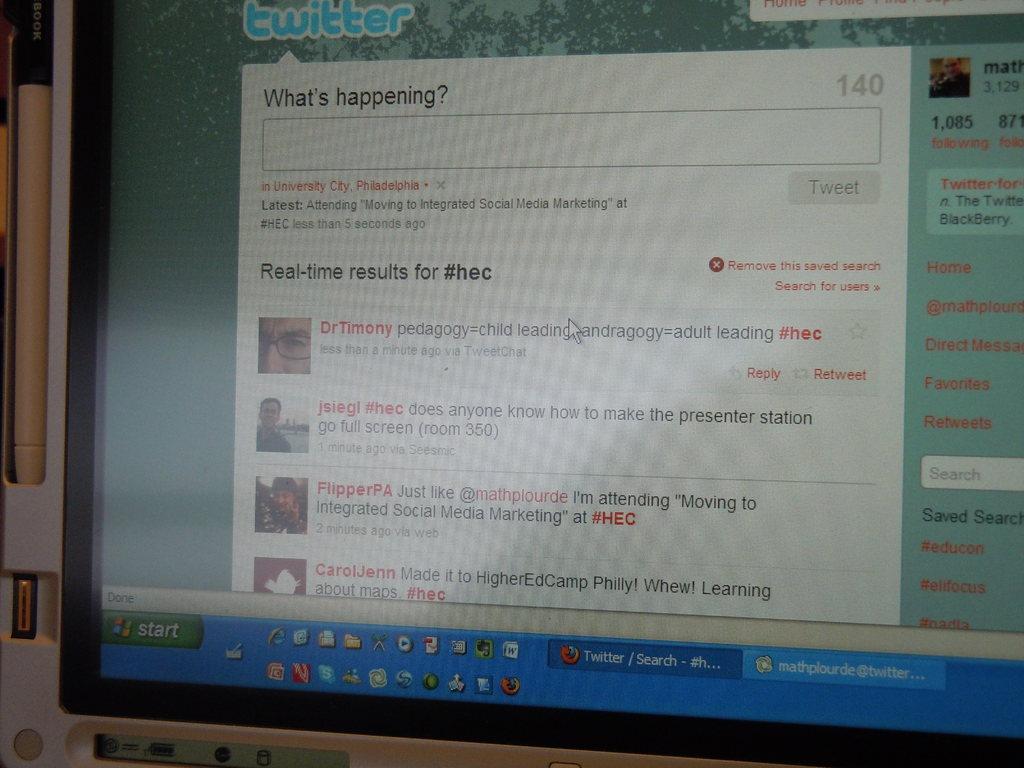What website are they on?
Offer a terse response. Twitter. 